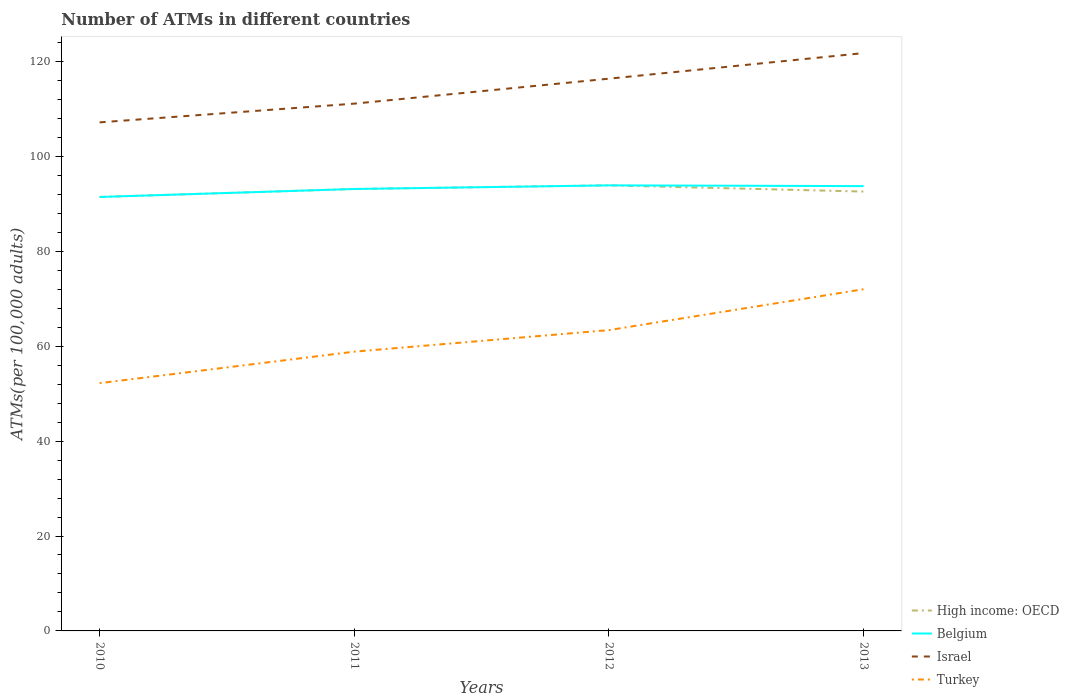Does the line corresponding to High income: OECD intersect with the line corresponding to Turkey?
Your answer should be very brief. No. Across all years, what is the maximum number of ATMs in High income: OECD?
Your response must be concise. 91.44. What is the total number of ATMs in Israel in the graph?
Provide a short and direct response. -9.21. What is the difference between the highest and the second highest number of ATMs in Israel?
Keep it short and to the point. 14.6. How many years are there in the graph?
Keep it short and to the point. 4. Are the values on the major ticks of Y-axis written in scientific E-notation?
Your answer should be compact. No. Where does the legend appear in the graph?
Offer a very short reply. Bottom right. How many legend labels are there?
Your answer should be very brief. 4. How are the legend labels stacked?
Offer a terse response. Vertical. What is the title of the graph?
Your response must be concise. Number of ATMs in different countries. Does "American Samoa" appear as one of the legend labels in the graph?
Your answer should be very brief. No. What is the label or title of the X-axis?
Ensure brevity in your answer.  Years. What is the label or title of the Y-axis?
Provide a short and direct response. ATMs(per 100,0 adults). What is the ATMs(per 100,000 adults) of High income: OECD in 2010?
Make the answer very short. 91.44. What is the ATMs(per 100,000 adults) in Belgium in 2010?
Ensure brevity in your answer.  91.44. What is the ATMs(per 100,000 adults) of Israel in 2010?
Your answer should be very brief. 107.16. What is the ATMs(per 100,000 adults) in Turkey in 2010?
Your response must be concise. 52.21. What is the ATMs(per 100,000 adults) in High income: OECD in 2011?
Provide a succinct answer. 93.12. What is the ATMs(per 100,000 adults) in Belgium in 2011?
Provide a succinct answer. 93.12. What is the ATMs(per 100,000 adults) of Israel in 2011?
Give a very brief answer. 111.1. What is the ATMs(per 100,000 adults) in Turkey in 2011?
Ensure brevity in your answer.  58.84. What is the ATMs(per 100,000 adults) in High income: OECD in 2012?
Your response must be concise. 93.88. What is the ATMs(per 100,000 adults) of Belgium in 2012?
Keep it short and to the point. 93.88. What is the ATMs(per 100,000 adults) of Israel in 2012?
Your answer should be compact. 116.36. What is the ATMs(per 100,000 adults) in Turkey in 2012?
Provide a short and direct response. 63.39. What is the ATMs(per 100,000 adults) in High income: OECD in 2013?
Your answer should be compact. 92.57. What is the ATMs(per 100,000 adults) in Belgium in 2013?
Your response must be concise. 93.73. What is the ATMs(per 100,000 adults) in Israel in 2013?
Provide a short and direct response. 121.76. What is the ATMs(per 100,000 adults) in Turkey in 2013?
Keep it short and to the point. 72. Across all years, what is the maximum ATMs(per 100,000 adults) of High income: OECD?
Offer a terse response. 93.88. Across all years, what is the maximum ATMs(per 100,000 adults) in Belgium?
Provide a succinct answer. 93.88. Across all years, what is the maximum ATMs(per 100,000 adults) of Israel?
Offer a terse response. 121.76. Across all years, what is the maximum ATMs(per 100,000 adults) of Turkey?
Your answer should be compact. 72. Across all years, what is the minimum ATMs(per 100,000 adults) in High income: OECD?
Your answer should be very brief. 91.44. Across all years, what is the minimum ATMs(per 100,000 adults) in Belgium?
Your answer should be very brief. 91.44. Across all years, what is the minimum ATMs(per 100,000 adults) of Israel?
Your response must be concise. 107.16. Across all years, what is the minimum ATMs(per 100,000 adults) of Turkey?
Keep it short and to the point. 52.21. What is the total ATMs(per 100,000 adults) in High income: OECD in the graph?
Keep it short and to the point. 371.01. What is the total ATMs(per 100,000 adults) of Belgium in the graph?
Ensure brevity in your answer.  372.17. What is the total ATMs(per 100,000 adults) of Israel in the graph?
Provide a short and direct response. 456.38. What is the total ATMs(per 100,000 adults) in Turkey in the graph?
Provide a short and direct response. 246.44. What is the difference between the ATMs(per 100,000 adults) of High income: OECD in 2010 and that in 2011?
Give a very brief answer. -1.68. What is the difference between the ATMs(per 100,000 adults) of Belgium in 2010 and that in 2011?
Offer a very short reply. -1.68. What is the difference between the ATMs(per 100,000 adults) in Israel in 2010 and that in 2011?
Provide a short and direct response. -3.95. What is the difference between the ATMs(per 100,000 adults) of Turkey in 2010 and that in 2011?
Keep it short and to the point. -6.64. What is the difference between the ATMs(per 100,000 adults) of High income: OECD in 2010 and that in 2012?
Make the answer very short. -2.45. What is the difference between the ATMs(per 100,000 adults) of Belgium in 2010 and that in 2012?
Give a very brief answer. -2.45. What is the difference between the ATMs(per 100,000 adults) of Israel in 2010 and that in 2012?
Your response must be concise. -9.21. What is the difference between the ATMs(per 100,000 adults) of Turkey in 2010 and that in 2012?
Give a very brief answer. -11.18. What is the difference between the ATMs(per 100,000 adults) in High income: OECD in 2010 and that in 2013?
Provide a short and direct response. -1.14. What is the difference between the ATMs(per 100,000 adults) of Belgium in 2010 and that in 2013?
Keep it short and to the point. -2.29. What is the difference between the ATMs(per 100,000 adults) in Israel in 2010 and that in 2013?
Your answer should be very brief. -14.6. What is the difference between the ATMs(per 100,000 adults) of Turkey in 2010 and that in 2013?
Make the answer very short. -19.8. What is the difference between the ATMs(per 100,000 adults) in High income: OECD in 2011 and that in 2012?
Offer a terse response. -0.77. What is the difference between the ATMs(per 100,000 adults) in Belgium in 2011 and that in 2012?
Keep it short and to the point. -0.77. What is the difference between the ATMs(per 100,000 adults) in Israel in 2011 and that in 2012?
Your answer should be very brief. -5.26. What is the difference between the ATMs(per 100,000 adults) of Turkey in 2011 and that in 2012?
Keep it short and to the point. -4.54. What is the difference between the ATMs(per 100,000 adults) of High income: OECD in 2011 and that in 2013?
Offer a terse response. 0.54. What is the difference between the ATMs(per 100,000 adults) of Belgium in 2011 and that in 2013?
Your answer should be compact. -0.61. What is the difference between the ATMs(per 100,000 adults) in Israel in 2011 and that in 2013?
Your response must be concise. -10.65. What is the difference between the ATMs(per 100,000 adults) in Turkey in 2011 and that in 2013?
Provide a succinct answer. -13.16. What is the difference between the ATMs(per 100,000 adults) of High income: OECD in 2012 and that in 2013?
Provide a succinct answer. 1.31. What is the difference between the ATMs(per 100,000 adults) of Belgium in 2012 and that in 2013?
Offer a terse response. 0.16. What is the difference between the ATMs(per 100,000 adults) in Israel in 2012 and that in 2013?
Give a very brief answer. -5.39. What is the difference between the ATMs(per 100,000 adults) in Turkey in 2012 and that in 2013?
Give a very brief answer. -8.62. What is the difference between the ATMs(per 100,000 adults) of High income: OECD in 2010 and the ATMs(per 100,000 adults) of Belgium in 2011?
Make the answer very short. -1.68. What is the difference between the ATMs(per 100,000 adults) in High income: OECD in 2010 and the ATMs(per 100,000 adults) in Israel in 2011?
Your response must be concise. -19.67. What is the difference between the ATMs(per 100,000 adults) of High income: OECD in 2010 and the ATMs(per 100,000 adults) of Turkey in 2011?
Make the answer very short. 32.59. What is the difference between the ATMs(per 100,000 adults) in Belgium in 2010 and the ATMs(per 100,000 adults) in Israel in 2011?
Ensure brevity in your answer.  -19.67. What is the difference between the ATMs(per 100,000 adults) in Belgium in 2010 and the ATMs(per 100,000 adults) in Turkey in 2011?
Give a very brief answer. 32.59. What is the difference between the ATMs(per 100,000 adults) of Israel in 2010 and the ATMs(per 100,000 adults) of Turkey in 2011?
Provide a short and direct response. 48.31. What is the difference between the ATMs(per 100,000 adults) in High income: OECD in 2010 and the ATMs(per 100,000 adults) in Belgium in 2012?
Give a very brief answer. -2.45. What is the difference between the ATMs(per 100,000 adults) in High income: OECD in 2010 and the ATMs(per 100,000 adults) in Israel in 2012?
Offer a very short reply. -24.93. What is the difference between the ATMs(per 100,000 adults) of High income: OECD in 2010 and the ATMs(per 100,000 adults) of Turkey in 2012?
Offer a very short reply. 28.05. What is the difference between the ATMs(per 100,000 adults) of Belgium in 2010 and the ATMs(per 100,000 adults) of Israel in 2012?
Give a very brief answer. -24.93. What is the difference between the ATMs(per 100,000 adults) of Belgium in 2010 and the ATMs(per 100,000 adults) of Turkey in 2012?
Offer a terse response. 28.05. What is the difference between the ATMs(per 100,000 adults) of Israel in 2010 and the ATMs(per 100,000 adults) of Turkey in 2012?
Provide a succinct answer. 43.77. What is the difference between the ATMs(per 100,000 adults) in High income: OECD in 2010 and the ATMs(per 100,000 adults) in Belgium in 2013?
Offer a terse response. -2.29. What is the difference between the ATMs(per 100,000 adults) in High income: OECD in 2010 and the ATMs(per 100,000 adults) in Israel in 2013?
Your answer should be compact. -30.32. What is the difference between the ATMs(per 100,000 adults) in High income: OECD in 2010 and the ATMs(per 100,000 adults) in Turkey in 2013?
Your response must be concise. 19.43. What is the difference between the ATMs(per 100,000 adults) in Belgium in 2010 and the ATMs(per 100,000 adults) in Israel in 2013?
Offer a terse response. -30.32. What is the difference between the ATMs(per 100,000 adults) of Belgium in 2010 and the ATMs(per 100,000 adults) of Turkey in 2013?
Your answer should be very brief. 19.43. What is the difference between the ATMs(per 100,000 adults) in Israel in 2010 and the ATMs(per 100,000 adults) in Turkey in 2013?
Your answer should be very brief. 35.15. What is the difference between the ATMs(per 100,000 adults) of High income: OECD in 2011 and the ATMs(per 100,000 adults) of Belgium in 2012?
Offer a very short reply. -0.77. What is the difference between the ATMs(per 100,000 adults) of High income: OECD in 2011 and the ATMs(per 100,000 adults) of Israel in 2012?
Provide a succinct answer. -23.25. What is the difference between the ATMs(per 100,000 adults) of High income: OECD in 2011 and the ATMs(per 100,000 adults) of Turkey in 2012?
Provide a short and direct response. 29.73. What is the difference between the ATMs(per 100,000 adults) in Belgium in 2011 and the ATMs(per 100,000 adults) in Israel in 2012?
Provide a short and direct response. -23.25. What is the difference between the ATMs(per 100,000 adults) of Belgium in 2011 and the ATMs(per 100,000 adults) of Turkey in 2012?
Offer a terse response. 29.73. What is the difference between the ATMs(per 100,000 adults) in Israel in 2011 and the ATMs(per 100,000 adults) in Turkey in 2012?
Your answer should be compact. 47.72. What is the difference between the ATMs(per 100,000 adults) of High income: OECD in 2011 and the ATMs(per 100,000 adults) of Belgium in 2013?
Offer a terse response. -0.61. What is the difference between the ATMs(per 100,000 adults) in High income: OECD in 2011 and the ATMs(per 100,000 adults) in Israel in 2013?
Provide a succinct answer. -28.64. What is the difference between the ATMs(per 100,000 adults) in High income: OECD in 2011 and the ATMs(per 100,000 adults) in Turkey in 2013?
Your answer should be very brief. 21.11. What is the difference between the ATMs(per 100,000 adults) of Belgium in 2011 and the ATMs(per 100,000 adults) of Israel in 2013?
Keep it short and to the point. -28.64. What is the difference between the ATMs(per 100,000 adults) of Belgium in 2011 and the ATMs(per 100,000 adults) of Turkey in 2013?
Your response must be concise. 21.11. What is the difference between the ATMs(per 100,000 adults) of Israel in 2011 and the ATMs(per 100,000 adults) of Turkey in 2013?
Your response must be concise. 39.1. What is the difference between the ATMs(per 100,000 adults) in High income: OECD in 2012 and the ATMs(per 100,000 adults) in Belgium in 2013?
Provide a short and direct response. 0.16. What is the difference between the ATMs(per 100,000 adults) of High income: OECD in 2012 and the ATMs(per 100,000 adults) of Israel in 2013?
Provide a succinct answer. -27.87. What is the difference between the ATMs(per 100,000 adults) of High income: OECD in 2012 and the ATMs(per 100,000 adults) of Turkey in 2013?
Provide a succinct answer. 21.88. What is the difference between the ATMs(per 100,000 adults) in Belgium in 2012 and the ATMs(per 100,000 adults) in Israel in 2013?
Your answer should be compact. -27.87. What is the difference between the ATMs(per 100,000 adults) of Belgium in 2012 and the ATMs(per 100,000 adults) of Turkey in 2013?
Keep it short and to the point. 21.88. What is the difference between the ATMs(per 100,000 adults) of Israel in 2012 and the ATMs(per 100,000 adults) of Turkey in 2013?
Your response must be concise. 44.36. What is the average ATMs(per 100,000 adults) of High income: OECD per year?
Provide a succinct answer. 92.75. What is the average ATMs(per 100,000 adults) of Belgium per year?
Your answer should be compact. 93.04. What is the average ATMs(per 100,000 adults) in Israel per year?
Provide a succinct answer. 114.09. What is the average ATMs(per 100,000 adults) in Turkey per year?
Make the answer very short. 61.61. In the year 2010, what is the difference between the ATMs(per 100,000 adults) in High income: OECD and ATMs(per 100,000 adults) in Belgium?
Offer a very short reply. 0. In the year 2010, what is the difference between the ATMs(per 100,000 adults) of High income: OECD and ATMs(per 100,000 adults) of Israel?
Keep it short and to the point. -15.72. In the year 2010, what is the difference between the ATMs(per 100,000 adults) of High income: OECD and ATMs(per 100,000 adults) of Turkey?
Provide a short and direct response. 39.23. In the year 2010, what is the difference between the ATMs(per 100,000 adults) in Belgium and ATMs(per 100,000 adults) in Israel?
Offer a terse response. -15.72. In the year 2010, what is the difference between the ATMs(per 100,000 adults) in Belgium and ATMs(per 100,000 adults) in Turkey?
Your answer should be very brief. 39.23. In the year 2010, what is the difference between the ATMs(per 100,000 adults) of Israel and ATMs(per 100,000 adults) of Turkey?
Your answer should be very brief. 54.95. In the year 2011, what is the difference between the ATMs(per 100,000 adults) of High income: OECD and ATMs(per 100,000 adults) of Israel?
Provide a succinct answer. -17.98. In the year 2011, what is the difference between the ATMs(per 100,000 adults) of High income: OECD and ATMs(per 100,000 adults) of Turkey?
Keep it short and to the point. 34.27. In the year 2011, what is the difference between the ATMs(per 100,000 adults) of Belgium and ATMs(per 100,000 adults) of Israel?
Make the answer very short. -17.98. In the year 2011, what is the difference between the ATMs(per 100,000 adults) of Belgium and ATMs(per 100,000 adults) of Turkey?
Provide a succinct answer. 34.27. In the year 2011, what is the difference between the ATMs(per 100,000 adults) in Israel and ATMs(per 100,000 adults) in Turkey?
Give a very brief answer. 52.26. In the year 2012, what is the difference between the ATMs(per 100,000 adults) in High income: OECD and ATMs(per 100,000 adults) in Belgium?
Provide a succinct answer. 0. In the year 2012, what is the difference between the ATMs(per 100,000 adults) of High income: OECD and ATMs(per 100,000 adults) of Israel?
Make the answer very short. -22.48. In the year 2012, what is the difference between the ATMs(per 100,000 adults) in High income: OECD and ATMs(per 100,000 adults) in Turkey?
Provide a short and direct response. 30.5. In the year 2012, what is the difference between the ATMs(per 100,000 adults) of Belgium and ATMs(per 100,000 adults) of Israel?
Your answer should be very brief. -22.48. In the year 2012, what is the difference between the ATMs(per 100,000 adults) of Belgium and ATMs(per 100,000 adults) of Turkey?
Offer a terse response. 30.5. In the year 2012, what is the difference between the ATMs(per 100,000 adults) in Israel and ATMs(per 100,000 adults) in Turkey?
Provide a succinct answer. 52.98. In the year 2013, what is the difference between the ATMs(per 100,000 adults) in High income: OECD and ATMs(per 100,000 adults) in Belgium?
Give a very brief answer. -1.15. In the year 2013, what is the difference between the ATMs(per 100,000 adults) in High income: OECD and ATMs(per 100,000 adults) in Israel?
Give a very brief answer. -29.18. In the year 2013, what is the difference between the ATMs(per 100,000 adults) of High income: OECD and ATMs(per 100,000 adults) of Turkey?
Ensure brevity in your answer.  20.57. In the year 2013, what is the difference between the ATMs(per 100,000 adults) in Belgium and ATMs(per 100,000 adults) in Israel?
Your response must be concise. -28.03. In the year 2013, what is the difference between the ATMs(per 100,000 adults) of Belgium and ATMs(per 100,000 adults) of Turkey?
Make the answer very short. 21.72. In the year 2013, what is the difference between the ATMs(per 100,000 adults) of Israel and ATMs(per 100,000 adults) of Turkey?
Ensure brevity in your answer.  49.75. What is the ratio of the ATMs(per 100,000 adults) of High income: OECD in 2010 to that in 2011?
Your response must be concise. 0.98. What is the ratio of the ATMs(per 100,000 adults) of Belgium in 2010 to that in 2011?
Provide a short and direct response. 0.98. What is the ratio of the ATMs(per 100,000 adults) of Israel in 2010 to that in 2011?
Ensure brevity in your answer.  0.96. What is the ratio of the ATMs(per 100,000 adults) of Turkey in 2010 to that in 2011?
Keep it short and to the point. 0.89. What is the ratio of the ATMs(per 100,000 adults) of High income: OECD in 2010 to that in 2012?
Your answer should be compact. 0.97. What is the ratio of the ATMs(per 100,000 adults) of Belgium in 2010 to that in 2012?
Provide a succinct answer. 0.97. What is the ratio of the ATMs(per 100,000 adults) in Israel in 2010 to that in 2012?
Provide a short and direct response. 0.92. What is the ratio of the ATMs(per 100,000 adults) of Turkey in 2010 to that in 2012?
Keep it short and to the point. 0.82. What is the ratio of the ATMs(per 100,000 adults) in Belgium in 2010 to that in 2013?
Your answer should be very brief. 0.98. What is the ratio of the ATMs(per 100,000 adults) in Israel in 2010 to that in 2013?
Give a very brief answer. 0.88. What is the ratio of the ATMs(per 100,000 adults) of Turkey in 2010 to that in 2013?
Your answer should be very brief. 0.72. What is the ratio of the ATMs(per 100,000 adults) of Israel in 2011 to that in 2012?
Your answer should be compact. 0.95. What is the ratio of the ATMs(per 100,000 adults) of Turkey in 2011 to that in 2012?
Keep it short and to the point. 0.93. What is the ratio of the ATMs(per 100,000 adults) in High income: OECD in 2011 to that in 2013?
Provide a succinct answer. 1.01. What is the ratio of the ATMs(per 100,000 adults) of Israel in 2011 to that in 2013?
Provide a short and direct response. 0.91. What is the ratio of the ATMs(per 100,000 adults) in Turkey in 2011 to that in 2013?
Make the answer very short. 0.82. What is the ratio of the ATMs(per 100,000 adults) of High income: OECD in 2012 to that in 2013?
Ensure brevity in your answer.  1.01. What is the ratio of the ATMs(per 100,000 adults) in Israel in 2012 to that in 2013?
Provide a succinct answer. 0.96. What is the ratio of the ATMs(per 100,000 adults) of Turkey in 2012 to that in 2013?
Offer a terse response. 0.88. What is the difference between the highest and the second highest ATMs(per 100,000 adults) in High income: OECD?
Offer a terse response. 0.77. What is the difference between the highest and the second highest ATMs(per 100,000 adults) in Belgium?
Your response must be concise. 0.16. What is the difference between the highest and the second highest ATMs(per 100,000 adults) in Israel?
Your answer should be very brief. 5.39. What is the difference between the highest and the second highest ATMs(per 100,000 adults) of Turkey?
Your answer should be very brief. 8.62. What is the difference between the highest and the lowest ATMs(per 100,000 adults) of High income: OECD?
Offer a very short reply. 2.45. What is the difference between the highest and the lowest ATMs(per 100,000 adults) in Belgium?
Your answer should be very brief. 2.45. What is the difference between the highest and the lowest ATMs(per 100,000 adults) in Israel?
Keep it short and to the point. 14.6. What is the difference between the highest and the lowest ATMs(per 100,000 adults) of Turkey?
Ensure brevity in your answer.  19.8. 